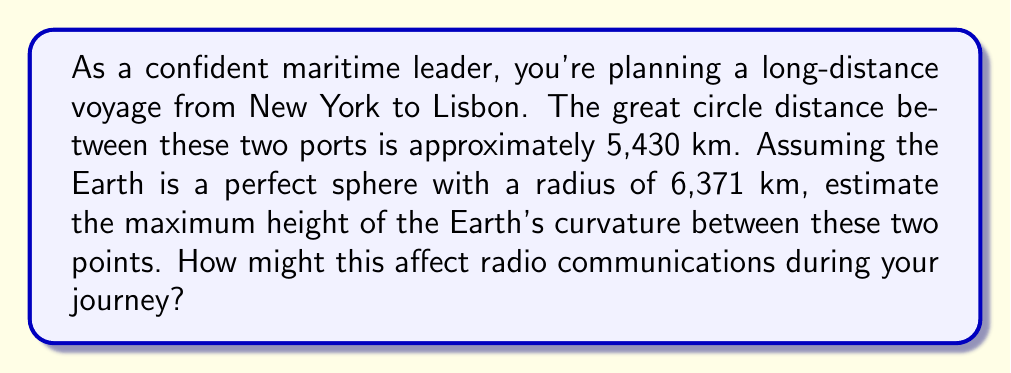What is the answer to this math problem? To solve this problem, we'll use the properties of a circular segment. The Earth's curvature between two points forms an arc, and we need to find the maximum height of this arc above the straight line connecting the two points.

1. Let's define our variables:
   $R$ = Earth's radius = 6,371 km
   $d$ = Great circle distance = 5,430 km
   $h$ = Maximum height of Earth's curvature (what we're solving for)

2. The formula for the maximum height of a circular segment is:

   $$h = R - \sqrt{R^2 - (\frac{d}{2})^2}$$

3. Let's substitute our values:

   $$h = 6371 - \sqrt{6371^2 - (\frac{5430}{2})^2}$$

4. Simplify:

   $$h = 6371 - \sqrt{40589641 - 7442025}$$
   $$h = 6371 - \sqrt{33147616}$$
   $$h = 6371 - 5757.39$$
   $$h \approx 613.61 \text{ km}$$

5. Round to a reasonable number of significant figures:

   $$h \approx 614 \text{ km}$$

This curvature can significantly affect radio communications, especially those relying on line-of-sight transmission. VHF radio, commonly used in maritime operations, is limited by the horizon. The radio horizon is approximately 30% farther than the visual horizon due to atmospheric refraction, but it's still affected by Earth's curvature. This means that for reliable long-distance communication, you may need to rely on other methods such as HF radio, satellite communication, or a series of relay stations.

[asy]
import geometry;

size(300,150);

real R = 100;
real d = 85;
real h = R - sqrt(R^2 - (d/2)^2);

pair O = (0,0);
pair A = (-d/2, 0);
pair B = (d/2, 0);
pair C = (0, R-h);

draw(circle(O,R), blue);
draw(A--B, red);
draw(O--C, dashed);

label("Earth's surface", C, N);
label("Straight line path", (0,-2), S);
label("h", (-d/4, h/2), W);

dot("A", A, SW);
dot("B", B, SE);
[/asy]
Answer: The maximum height of the Earth's curvature between New York and Lisbon is approximately 614 km. This significant curvature can affect radio communications, potentially limiting the range of VHF radio and necessitating the use of alternative communication methods for reliable long-distance maritime operations. 